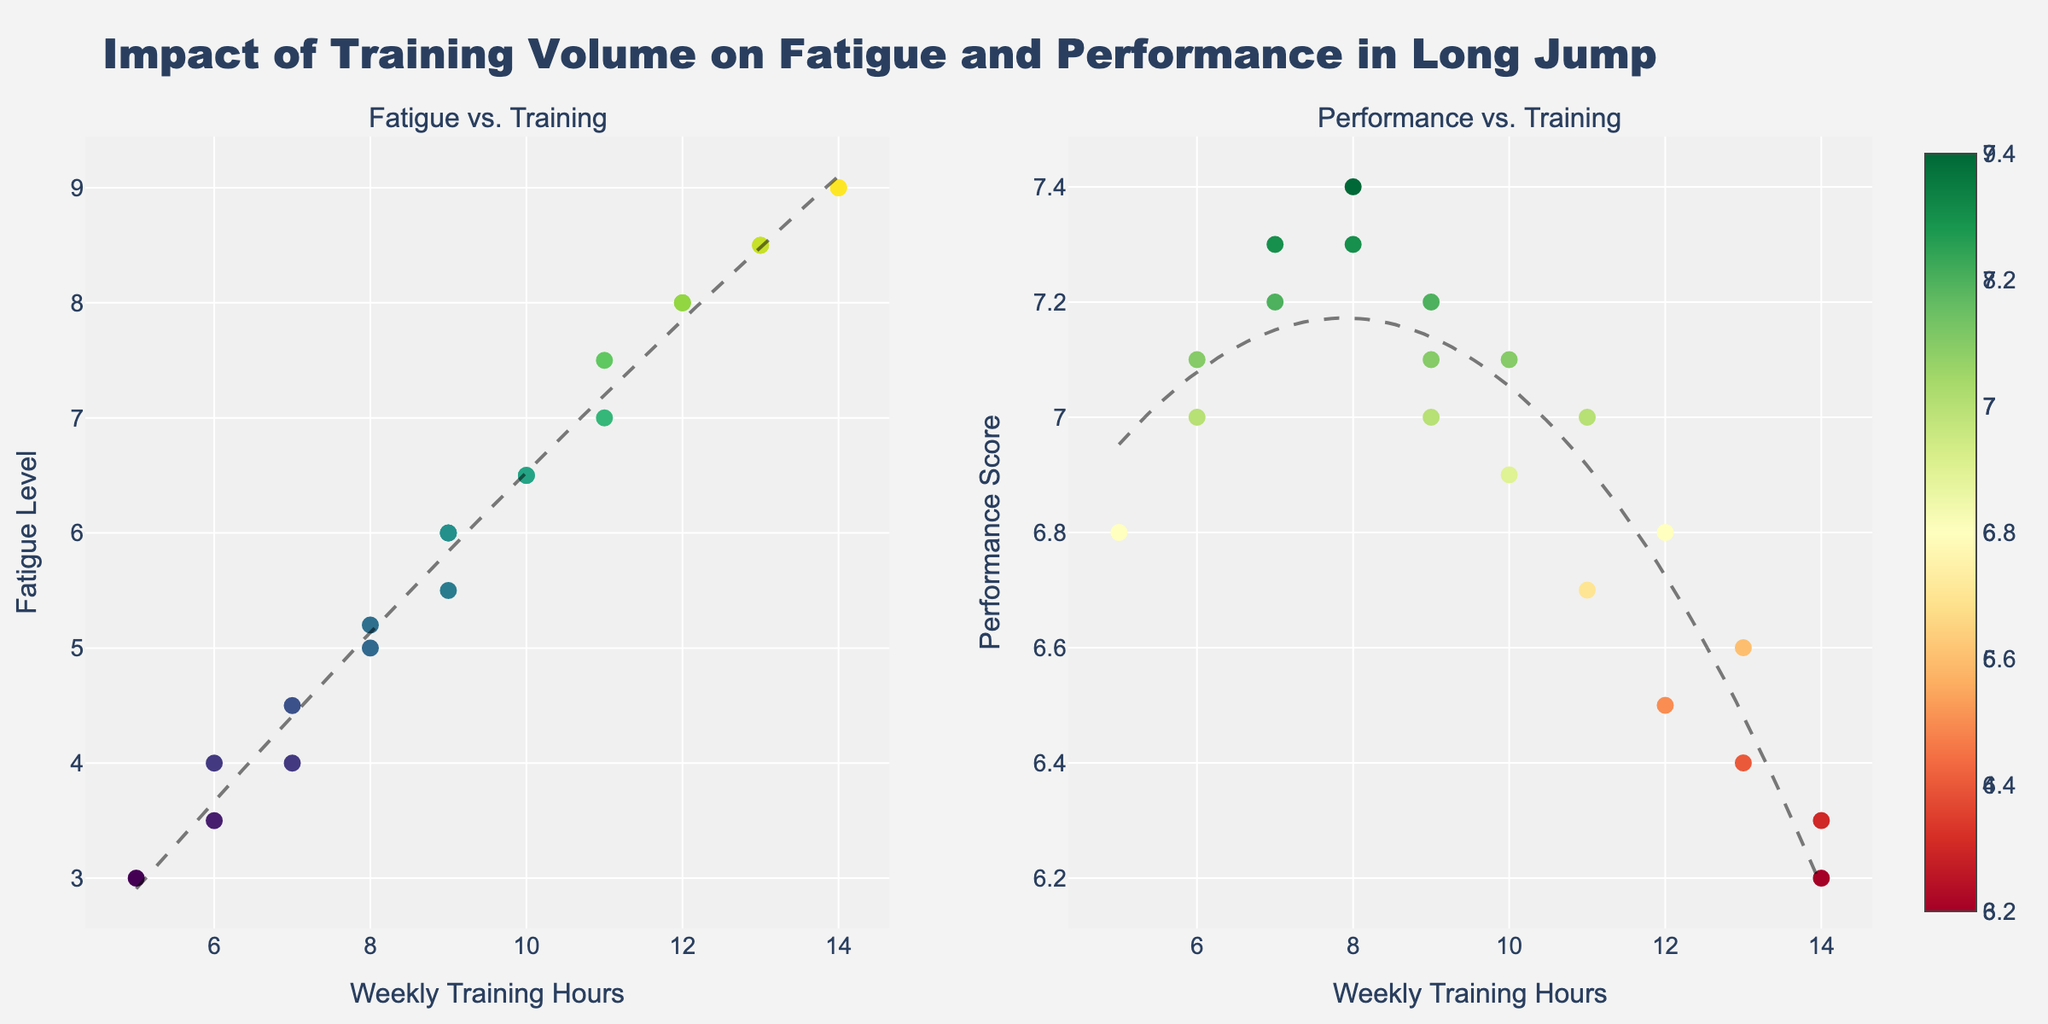What is the title of the figure? The title is typically placed at the top of the figure, summarizing what the plot is about. In this case, it states the main theme: the impact of training volume on fatigue and performance in long jump.
Answer: "Impact of Training Volume on Fatigue and Performance in Long Jump" What does the x-axis represent? The x-axis is the horizontal line at the bottom of the plots that indicates the variable being compared along this axis. Here, it represents weekly training hours.
Answer: Weekly Training Hours What trend can you observe between weekly training hours and fatigue level? By examining the scatter plot on the left and the trend line added to it, we see that the fatigue level tends to increase as weekly training hours increase.
Answer: Fatigue tends to increase How does performance score change with weekly training hours? Observing the scatter plot on the right and its corresponding trend line, performance scores decrease as weekly training hours increase beyond a certain point.
Answer: Performance decreases What is the fatigue level when weekly training hours is 8? By locating the weekly training hours value of 8 on the x-axis of the left plot and checking the corresponding fatigue level, we see it's around 5-5.2.
Answer: 5-5.2 What is the highest Performance Score observed and at what weekly training hours does it occur? By observing the scatter plot on the right, the highest performance score is approximately 7.4, occurring around 8 weekly training hours.
Answer: 7.4 at 8 Compare fatigue levels at 6 and 12 weekly training hours. Identifying data points on the left plot, we find that fatigue level is approximately 3.5 at 6 hours and 8 at 12 hours. This shows a significant increase.
Answer: 3.5 and 8 Between 7 and 9 weekly training hours, what trend do you observe in the performance score? Looking at the scatter plot on the right, between these weekly training hours, the performance score initially rises slightly then begins to decline.
Answer: Slight rise then decline What can be inferred if an athlete's weekly training hours are 14? From both plots, at 14 weekly training hours, the athlete experiences high fatigue (around 9) and lower performance scores (around 6.2-6.3), suggesting overtraining.
Answer: High fatigue and lower performance Is there an optimal range of weekly training hours to balance fatigue and performance? By examining both plots, it appears that training between 7-9 hours weekly might be optimal as it balances moderate fatigue while maintaining a higher performance score.
Answer: 7-9 hours 